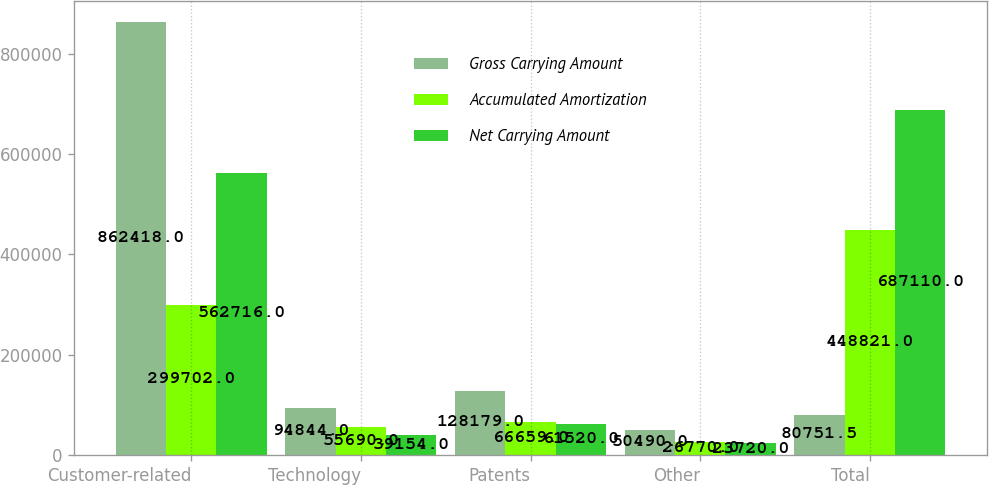Convert chart to OTSL. <chart><loc_0><loc_0><loc_500><loc_500><stacked_bar_chart><ecel><fcel>Customer-related<fcel>Technology<fcel>Patents<fcel>Other<fcel>Total<nl><fcel>Gross Carrying Amount<fcel>862418<fcel>94844<fcel>128179<fcel>50490<fcel>80751.5<nl><fcel>Accumulated Amortization<fcel>299702<fcel>55690<fcel>66659<fcel>26770<fcel>448821<nl><fcel>Net Carrying Amount<fcel>562716<fcel>39154<fcel>61520<fcel>23720<fcel>687110<nl></chart> 